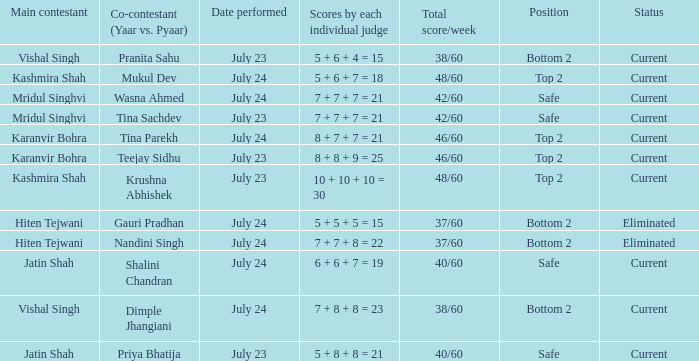Who is the co-contestant (yaar vs. Pyaar) with Vishal Singh as the main contestant? Pranita Sahu, Dimple Jhangiani. 